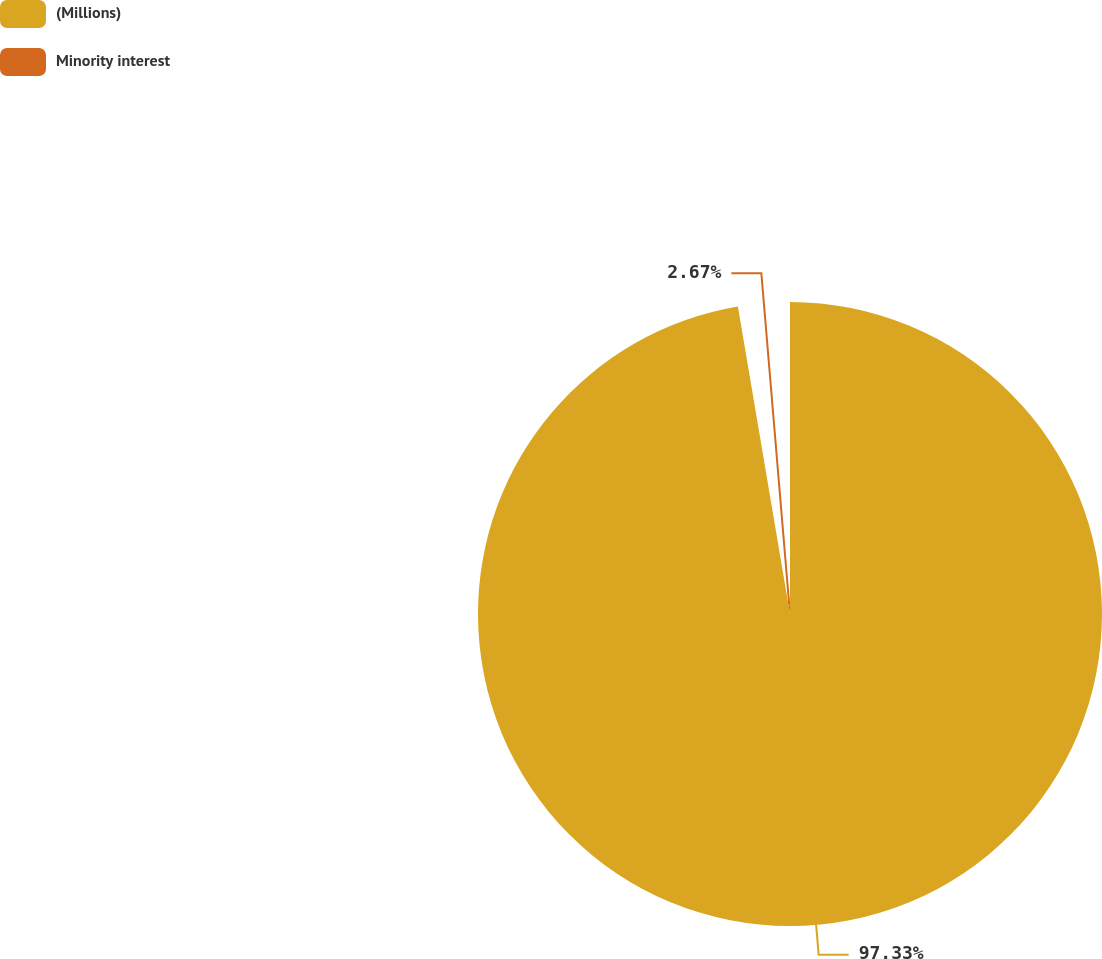Convert chart. <chart><loc_0><loc_0><loc_500><loc_500><pie_chart><fcel>(Millions)<fcel>Minority interest<nl><fcel>97.33%<fcel>2.67%<nl></chart> 